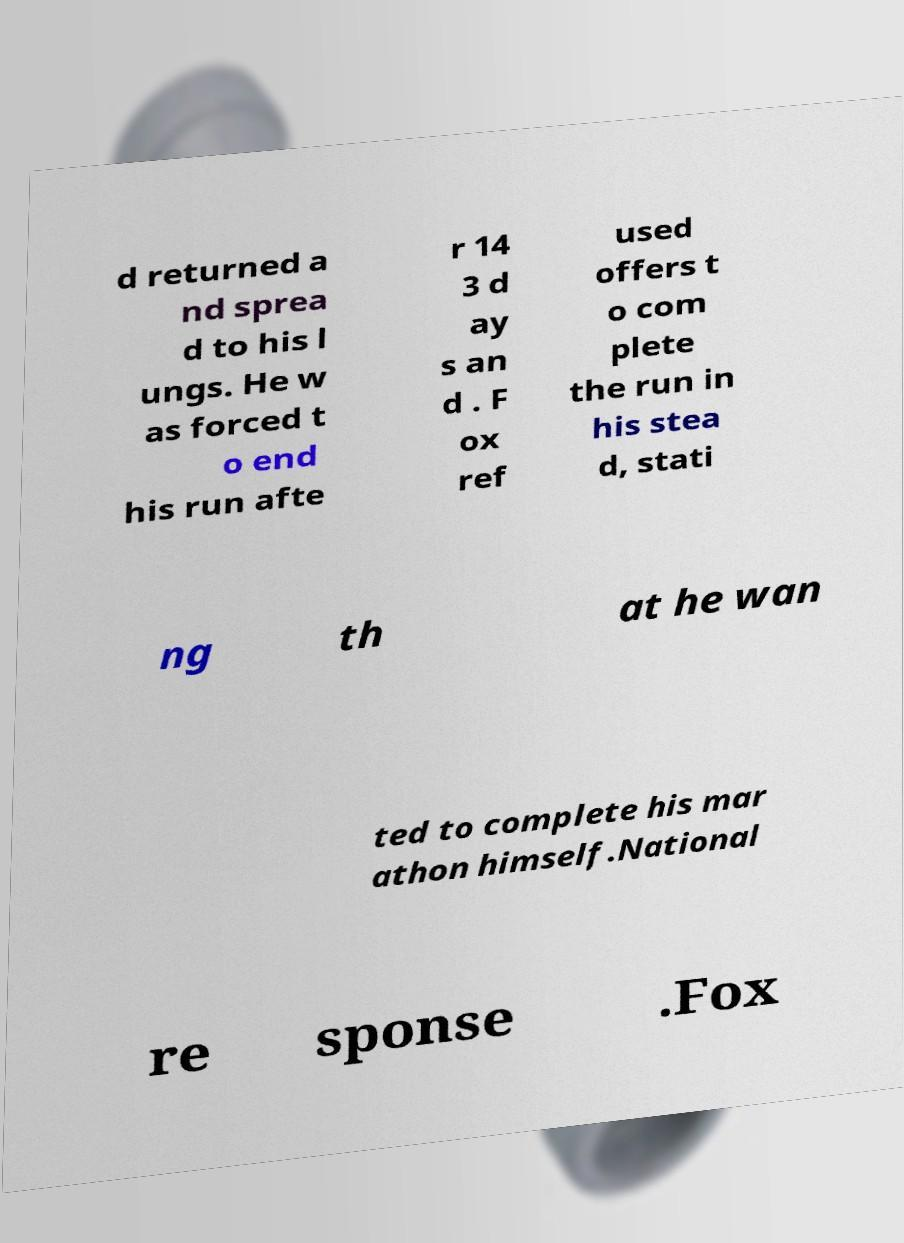Could you extract and type out the text from this image? d returned a nd sprea d to his l ungs. He w as forced t o end his run afte r 14 3 d ay s an d . F ox ref used offers t o com plete the run in his stea d, stati ng th at he wan ted to complete his mar athon himself.National re sponse .Fox 